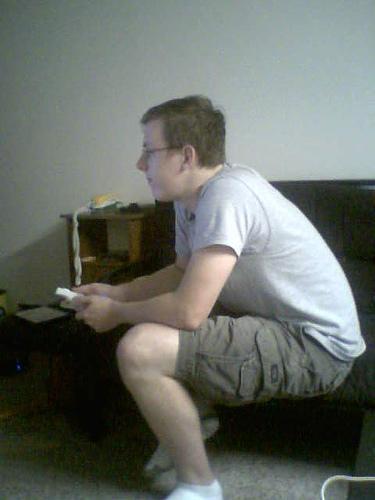What type of furniture is the boy sitting on?
Answer the question by selecting the correct answer among the 4 following choices and explain your choice with a short sentence. The answer should be formatted with the following format: `Answer: choice
Rationale: rationale.`
Options: Bench, sectional, chaise, futon. Answer: futon.
Rationale: It is a couch that resembles a mattress and is low to the ground. it is a common piece of furniture used by people this age. 